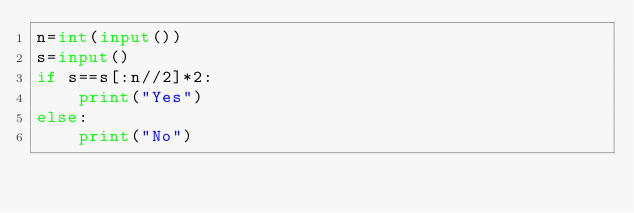Convert code to text. <code><loc_0><loc_0><loc_500><loc_500><_Python_>n=int(input())
s=input()
if s==s[:n//2]*2:
    print("Yes")
else:
    print("No")</code> 